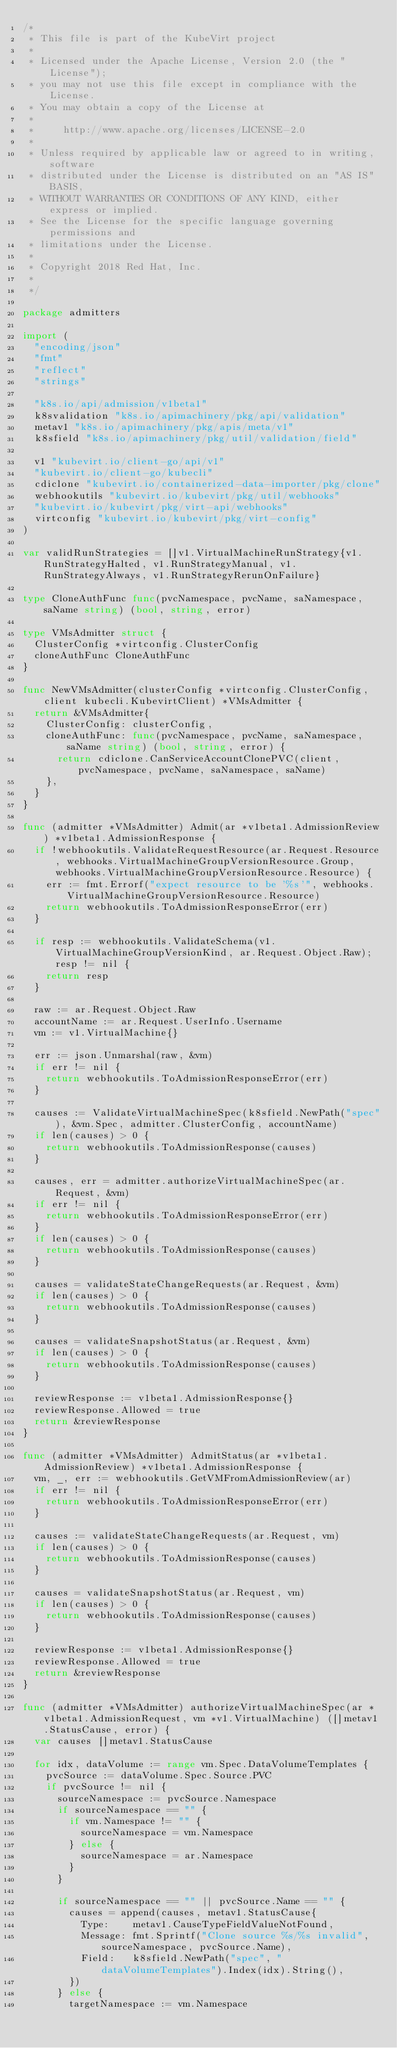Convert code to text. <code><loc_0><loc_0><loc_500><loc_500><_Go_>/*
 * This file is part of the KubeVirt project
 *
 * Licensed under the Apache License, Version 2.0 (the "License");
 * you may not use this file except in compliance with the License.
 * You may obtain a copy of the License at
 *
 *     http://www.apache.org/licenses/LICENSE-2.0
 *
 * Unless required by applicable law or agreed to in writing, software
 * distributed under the License is distributed on an "AS IS" BASIS,
 * WITHOUT WARRANTIES OR CONDITIONS OF ANY KIND, either express or implied.
 * See the License for the specific language governing permissions and
 * limitations under the License.
 *
 * Copyright 2018 Red Hat, Inc.
 *
 */

package admitters

import (
	"encoding/json"
	"fmt"
	"reflect"
	"strings"

	"k8s.io/api/admission/v1beta1"
	k8svalidation "k8s.io/apimachinery/pkg/api/validation"
	metav1 "k8s.io/apimachinery/pkg/apis/meta/v1"
	k8sfield "k8s.io/apimachinery/pkg/util/validation/field"

	v1 "kubevirt.io/client-go/api/v1"
	"kubevirt.io/client-go/kubecli"
	cdiclone "kubevirt.io/containerized-data-importer/pkg/clone"
	webhookutils "kubevirt.io/kubevirt/pkg/util/webhooks"
	"kubevirt.io/kubevirt/pkg/virt-api/webhooks"
	virtconfig "kubevirt.io/kubevirt/pkg/virt-config"
)

var validRunStrategies = []v1.VirtualMachineRunStrategy{v1.RunStrategyHalted, v1.RunStrategyManual, v1.RunStrategyAlways, v1.RunStrategyRerunOnFailure}

type CloneAuthFunc func(pvcNamespace, pvcName, saNamespace, saName string) (bool, string, error)

type VMsAdmitter struct {
	ClusterConfig *virtconfig.ClusterConfig
	cloneAuthFunc CloneAuthFunc
}

func NewVMsAdmitter(clusterConfig *virtconfig.ClusterConfig, client kubecli.KubevirtClient) *VMsAdmitter {
	return &VMsAdmitter{
		ClusterConfig: clusterConfig,
		cloneAuthFunc: func(pvcNamespace, pvcName, saNamespace, saName string) (bool, string, error) {
			return cdiclone.CanServiceAccountClonePVC(client, pvcNamespace, pvcName, saNamespace, saName)
		},
	}
}

func (admitter *VMsAdmitter) Admit(ar *v1beta1.AdmissionReview) *v1beta1.AdmissionResponse {
	if !webhookutils.ValidateRequestResource(ar.Request.Resource, webhooks.VirtualMachineGroupVersionResource.Group, webhooks.VirtualMachineGroupVersionResource.Resource) {
		err := fmt.Errorf("expect resource to be '%s'", webhooks.VirtualMachineGroupVersionResource.Resource)
		return webhookutils.ToAdmissionResponseError(err)
	}

	if resp := webhookutils.ValidateSchema(v1.VirtualMachineGroupVersionKind, ar.Request.Object.Raw); resp != nil {
		return resp
	}

	raw := ar.Request.Object.Raw
	accountName := ar.Request.UserInfo.Username
	vm := v1.VirtualMachine{}

	err := json.Unmarshal(raw, &vm)
	if err != nil {
		return webhookutils.ToAdmissionResponseError(err)
	}

	causes := ValidateVirtualMachineSpec(k8sfield.NewPath("spec"), &vm.Spec, admitter.ClusterConfig, accountName)
	if len(causes) > 0 {
		return webhookutils.ToAdmissionResponse(causes)
	}

	causes, err = admitter.authorizeVirtualMachineSpec(ar.Request, &vm)
	if err != nil {
		return webhookutils.ToAdmissionResponseError(err)
	}
	if len(causes) > 0 {
		return webhookutils.ToAdmissionResponse(causes)
	}

	causes = validateStateChangeRequests(ar.Request, &vm)
	if len(causes) > 0 {
		return webhookutils.ToAdmissionResponse(causes)
	}

	causes = validateSnapshotStatus(ar.Request, &vm)
	if len(causes) > 0 {
		return webhookutils.ToAdmissionResponse(causes)
	}

	reviewResponse := v1beta1.AdmissionResponse{}
	reviewResponse.Allowed = true
	return &reviewResponse
}

func (admitter *VMsAdmitter) AdmitStatus(ar *v1beta1.AdmissionReview) *v1beta1.AdmissionResponse {
	vm, _, err := webhookutils.GetVMFromAdmissionReview(ar)
	if err != nil {
		return webhookutils.ToAdmissionResponseError(err)
	}

	causes := validateStateChangeRequests(ar.Request, vm)
	if len(causes) > 0 {
		return webhookutils.ToAdmissionResponse(causes)
	}

	causes = validateSnapshotStatus(ar.Request, vm)
	if len(causes) > 0 {
		return webhookutils.ToAdmissionResponse(causes)
	}

	reviewResponse := v1beta1.AdmissionResponse{}
	reviewResponse.Allowed = true
	return &reviewResponse
}

func (admitter *VMsAdmitter) authorizeVirtualMachineSpec(ar *v1beta1.AdmissionRequest, vm *v1.VirtualMachine) ([]metav1.StatusCause, error) {
	var causes []metav1.StatusCause

	for idx, dataVolume := range vm.Spec.DataVolumeTemplates {
		pvcSource := dataVolume.Spec.Source.PVC
		if pvcSource != nil {
			sourceNamespace := pvcSource.Namespace
			if sourceNamespace == "" {
				if vm.Namespace != "" {
					sourceNamespace = vm.Namespace
				} else {
					sourceNamespace = ar.Namespace
				}
			}

			if sourceNamespace == "" || pvcSource.Name == "" {
				causes = append(causes, metav1.StatusCause{
					Type:    metav1.CauseTypeFieldValueNotFound,
					Message: fmt.Sprintf("Clone source %s/%s invalid", sourceNamespace, pvcSource.Name),
					Field:   k8sfield.NewPath("spec", "dataVolumeTemplates").Index(idx).String(),
				})
			} else {
				targetNamespace := vm.Namespace</code> 